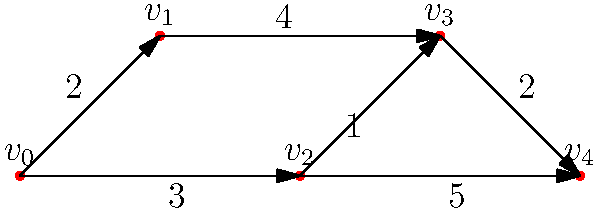Given the directed acyclic graph representing a renewable energy production and storage scheduling problem, where vertices represent tasks and edge weights represent time dependencies between tasks, what is the minimum time required to complete all tasks, assuming an unlimited number of processors? To solve this problem, we need to find the critical path in the directed acyclic graph (DAG). The critical path is the longest path from the start node to the end node, which determines the minimum time required to complete all tasks. Here's how we can find it:

1. Identify the start and end nodes:
   - Start node: $v_0$ (no incoming edges)
   - End node: $v_4$ (no outgoing edges)

2. Calculate the earliest start time (EST) for each node:
   - $EST(v_0) = 0$
   - $EST(v_1) = EST(v_0) + 2 = 2$
   - $EST(v_2) = EST(v_0) + 3 = 3$
   - $EST(v_3) = \max(EST(v_1) + 4, EST(v_2) + 1) = \max(6, 4) = 6$
   - $EST(v_4) = \max(EST(v_2) + 5, EST(v_3) + 2) = \max(8, 8) = 8$

3. The minimum time required to complete all tasks is the EST of the end node, which is 8.

This approach assumes that we have an unlimited number of processors, allowing parallel execution of tasks when possible.
Answer: 8 time units 